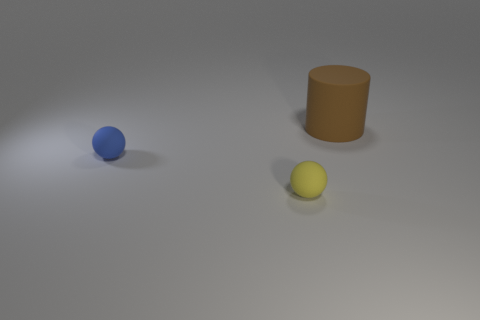Does the yellow matte object have the same size as the matte object that is behind the small blue sphere?
Keep it short and to the point. No. What is the shape of the thing that is on the right side of the blue ball and to the left of the big brown matte thing?
Ensure brevity in your answer.  Sphere. There is a blue thing that is the same material as the big cylinder; what is its size?
Your answer should be very brief. Small. There is a big brown matte thing behind the yellow rubber thing; how many tiny matte things are behind it?
Give a very brief answer. 0. Does the thing that is on the right side of the yellow thing have the same material as the blue sphere?
Your response must be concise. Yes. Is there any other thing that has the same material as the brown object?
Keep it short and to the point. Yes. There is a object to the left of the small thing in front of the blue object; what is its size?
Give a very brief answer. Small. How big is the ball behind the tiny thing that is on the right side of the small rubber thing on the left side of the yellow rubber object?
Provide a short and direct response. Small. There is a tiny rubber object on the left side of the tiny yellow rubber sphere; is its shape the same as the object that is in front of the blue sphere?
Make the answer very short. Yes. How many other things are there of the same color as the big cylinder?
Offer a terse response. 0. 